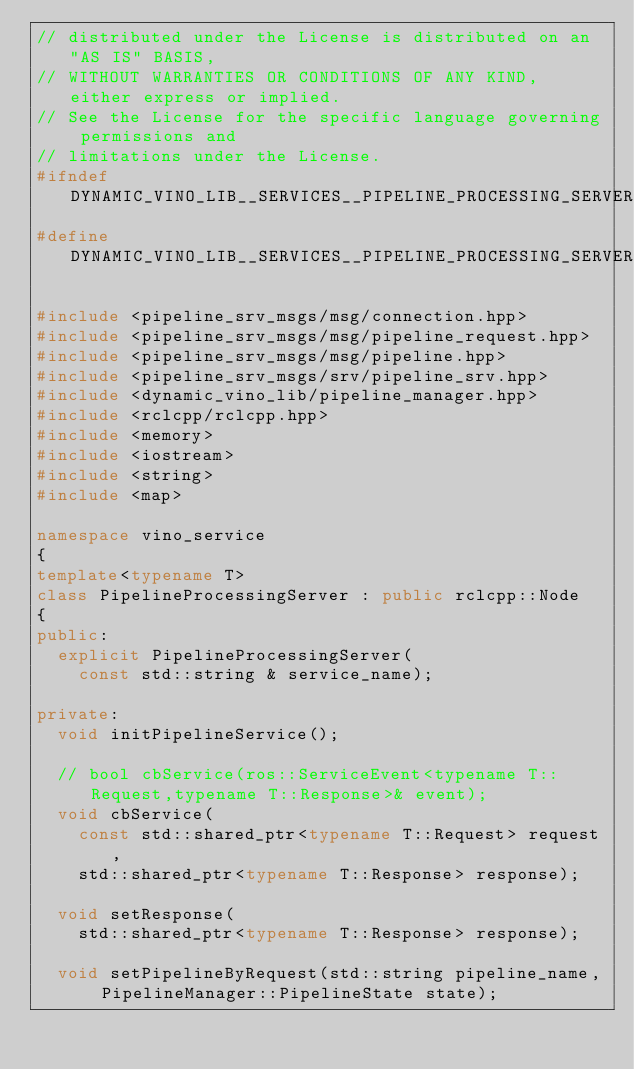Convert code to text. <code><loc_0><loc_0><loc_500><loc_500><_C++_>// distributed under the License is distributed on an "AS IS" BASIS,
// WITHOUT WARRANTIES OR CONDITIONS OF ANY KIND, either express or implied.
// See the License for the specific language governing permissions and
// limitations under the License.
#ifndef DYNAMIC_VINO_LIB__SERVICES__PIPELINE_PROCESSING_SERVER_HPP_
#define DYNAMIC_VINO_LIB__SERVICES__PIPELINE_PROCESSING_SERVER_HPP_

#include <pipeline_srv_msgs/msg/connection.hpp>
#include <pipeline_srv_msgs/msg/pipeline_request.hpp>
#include <pipeline_srv_msgs/msg/pipeline.hpp>
#include <pipeline_srv_msgs/srv/pipeline_srv.hpp>
#include <dynamic_vino_lib/pipeline_manager.hpp>
#include <rclcpp/rclcpp.hpp>
#include <memory>
#include <iostream>
#include <string>
#include <map>

namespace vino_service
{
template<typename T>
class PipelineProcessingServer : public rclcpp::Node
{
public:
  explicit PipelineProcessingServer(
    const std::string & service_name);

private:
  void initPipelineService();

  // bool cbService(ros::ServiceEvent<typename T::Request,typename T::Response>& event);
  void cbService(
    const std::shared_ptr<typename T::Request> request,
    std::shared_ptr<typename T::Response> response);

  void setResponse(
    std::shared_ptr<typename T::Response> response);

  void setPipelineByRequest(std::string pipeline_name, PipelineManager::PipelineState state);
</code> 